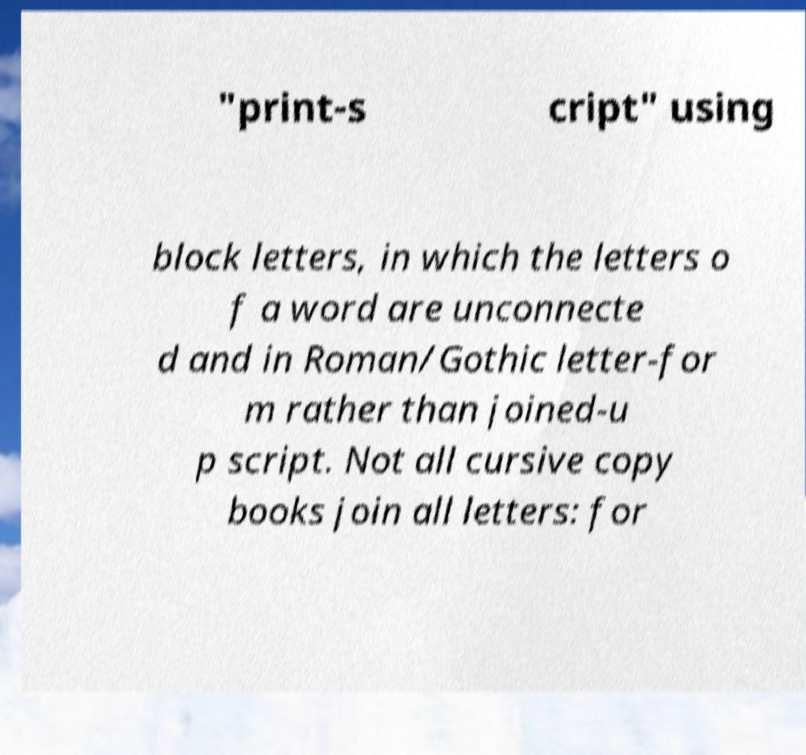Please identify and transcribe the text found in this image. "print-s cript" using block letters, in which the letters o f a word are unconnecte d and in Roman/Gothic letter-for m rather than joined-u p script. Not all cursive copy books join all letters: for 